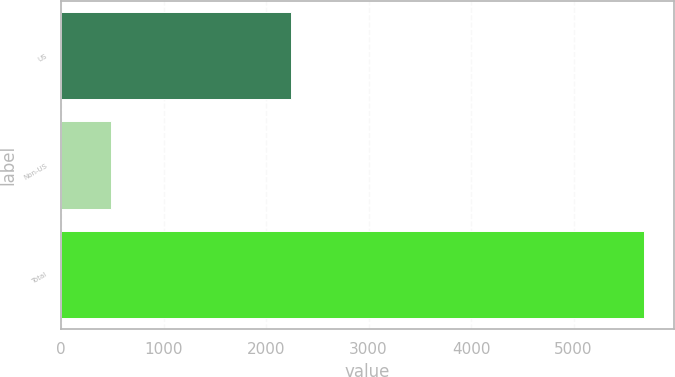Convert chart to OTSL. <chart><loc_0><loc_0><loc_500><loc_500><bar_chart><fcel>US<fcel>Non-US<fcel>Total<nl><fcel>2247<fcel>489<fcel>5692<nl></chart> 